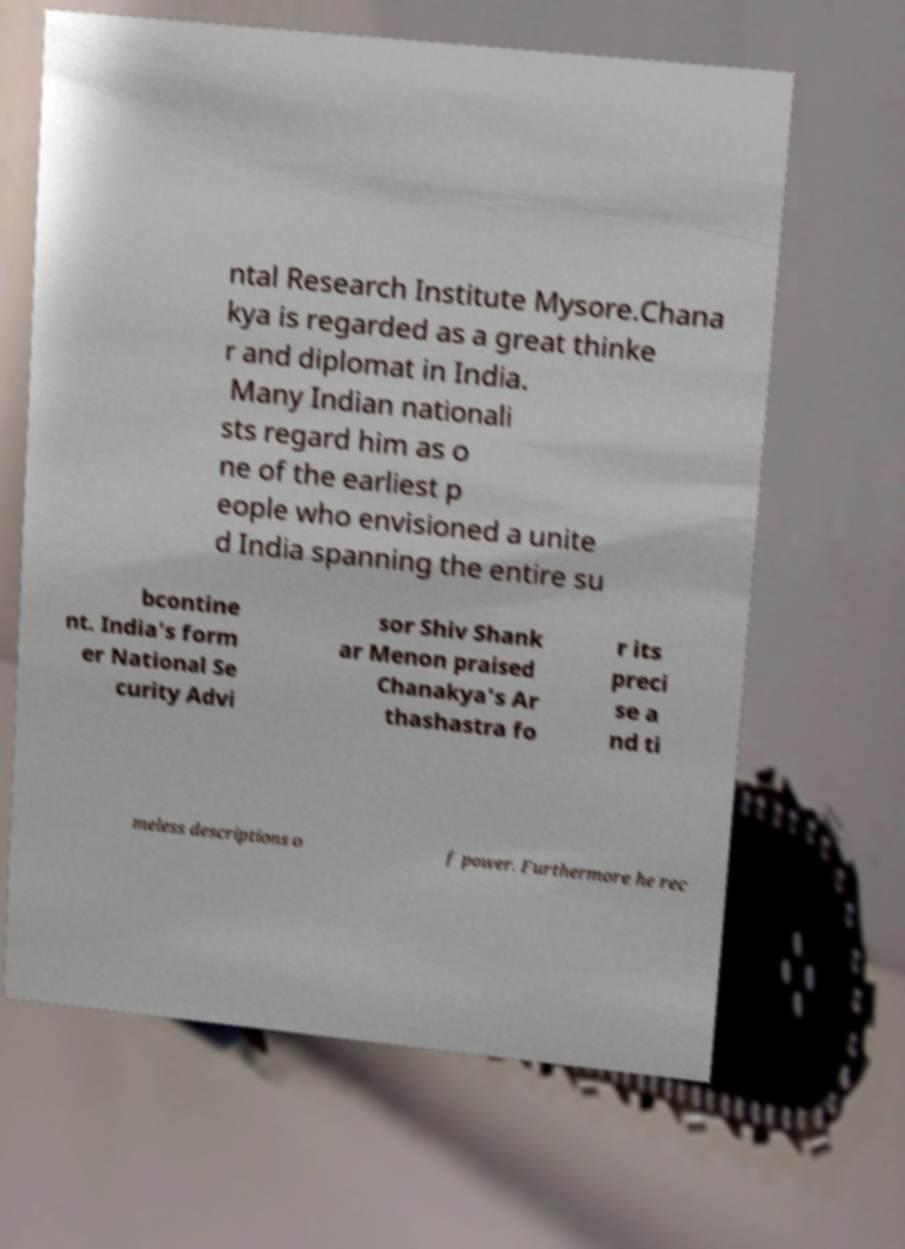Please identify and transcribe the text found in this image. ntal Research Institute Mysore.Chana kya is regarded as a great thinke r and diplomat in India. Many Indian nationali sts regard him as o ne of the earliest p eople who envisioned a unite d India spanning the entire su bcontine nt. India's form er National Se curity Advi sor Shiv Shank ar Menon praised Chanakya's Ar thashastra fo r its preci se a nd ti meless descriptions o f power. Furthermore he rec 